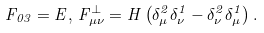Convert formula to latex. <formula><loc_0><loc_0><loc_500><loc_500>F _ { 0 3 } = E , \, F _ { \mu \nu } ^ { \perp } = H \left ( \delta _ { \mu } ^ { 2 } \delta _ { \nu } ^ { 1 } - \delta _ { \nu } ^ { 2 } \delta _ { \mu } ^ { 1 } \right ) .</formula> 